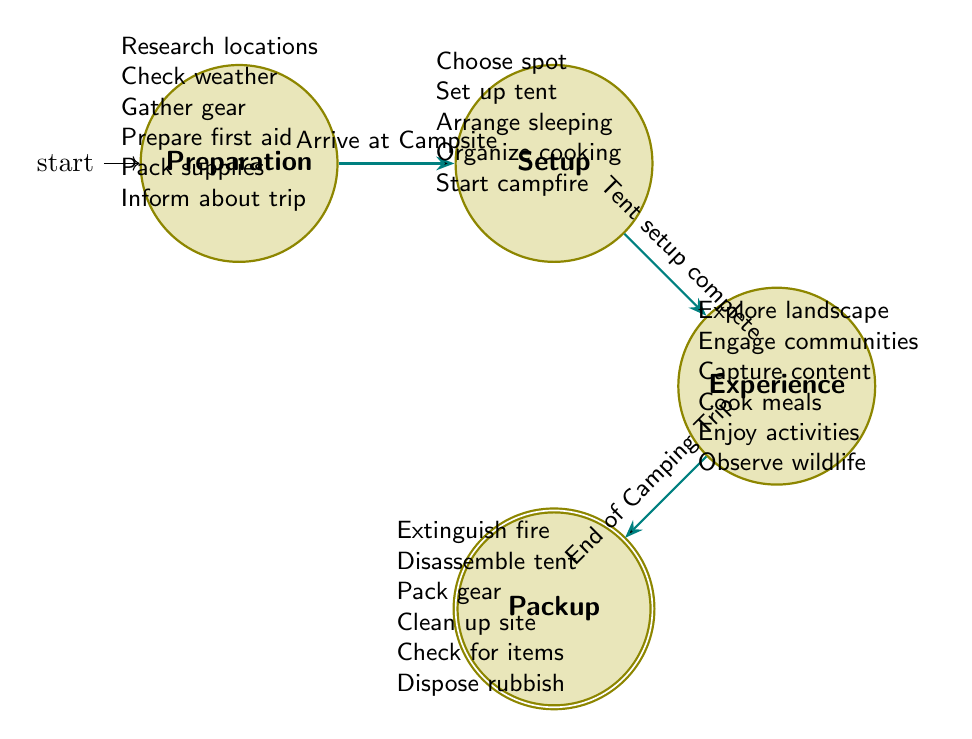What is the first state in the diagram? The first state in the diagram is indicated by being the initial state. It is labeled "Preparation", which is where the camping process starts.
Answer: Preparation How many states are represented in the diagram? The diagram lists four states connected by transitions. They are Preparation, Setup, Experience, and Packup. Therefore, the total number of states is four.
Answer: 4 What action is associated with the transition from Setup to Experience? The transition from Setup to Experience is triggered when "Tent setup complete". This indicates the completion of tent setup as a necessary condition to move to the Experience stage.
Answer: Tent setup complete What is the last action in the Packup stage? The actions in the Packup stage include "Extinguish Campfire", "Disassemble Tent", "Pack All Gear", "Clean Up Campsite", "Check for Left Behind Items", and "Dispose of Rubbish Responsibly". The last action listed in this stage is "Dispose of Rubbish Responsibly".
Answer: Dispose of Rubbish Responsibly Which state comes after Preparation? Following the Preparation state, the next state indicated by a transition is Setup. This state represents the actions taken after arriving at the campsite and setting up.
Answer: Setup What actions are involved in the Experience stage? The Experience stage encompasses several actions: "Explore Surrounding Landscape", "Engage with Local Communities", "Capture Photos and Videos for Blog", "Cook Outdoor Meals", "Enjoy Campfire Activities", and "Observe Local Wildlife". These tasks collectively define the Experience of camping.
Answer: Explore Surrounding Landscape, Engage with Local Communities, Capture Photos and Videos for Blog, Cook Outdoor Meals, Enjoy Campfire Activities, Observe Local Wildlife Which state is the accepting state in the diagram? The accepting state in the diagram is marked distinctly, and it indicates the end of the process. Here, the Packup state is identified as the final state in this finite state machine.
Answer: Packup What must happen before transitioning to Packup? The transition to Packup requires the action "End of Camping Trip" to occur. This signifies that all experiences during the camping have concluded and it is time to pack up.
Answer: End of Camping Trip What triggers the transition from Preparation to Setup? The transition from Preparation to Setup is triggered by the action "Arrive at Campsite". This shows that arriving at the campsite is necessary to begin the setup process.
Answer: Arrive at Campsite 